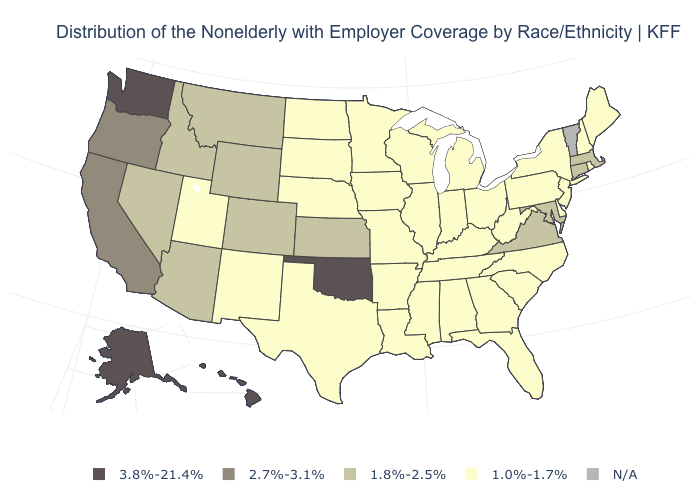What is the lowest value in the West?
Give a very brief answer. 1.0%-1.7%. What is the value of North Dakota?
Quick response, please. 1.0%-1.7%. Name the states that have a value in the range N/A?
Keep it brief. Vermont. Name the states that have a value in the range 1.0%-1.7%?
Quick response, please. Alabama, Arkansas, Delaware, Florida, Georgia, Illinois, Indiana, Iowa, Kentucky, Louisiana, Maine, Michigan, Minnesota, Mississippi, Missouri, Nebraska, New Hampshire, New Jersey, New Mexico, New York, North Carolina, North Dakota, Ohio, Pennsylvania, Rhode Island, South Carolina, South Dakota, Tennessee, Texas, Utah, West Virginia, Wisconsin. What is the value of Mississippi?
Give a very brief answer. 1.0%-1.7%. What is the value of Kentucky?
Short answer required. 1.0%-1.7%. Name the states that have a value in the range 3.8%-21.4%?
Concise answer only. Alaska, Hawaii, Oklahoma, Washington. Name the states that have a value in the range 3.8%-21.4%?
Write a very short answer. Alaska, Hawaii, Oklahoma, Washington. Name the states that have a value in the range 1.8%-2.5%?
Write a very short answer. Arizona, Colorado, Connecticut, Idaho, Kansas, Maryland, Massachusetts, Montana, Nevada, Virginia, Wyoming. Among the states that border North Carolina , which have the lowest value?
Give a very brief answer. Georgia, South Carolina, Tennessee. What is the value of Oklahoma?
Give a very brief answer. 3.8%-21.4%. Does Hawaii have the highest value in the USA?
Concise answer only. Yes. 